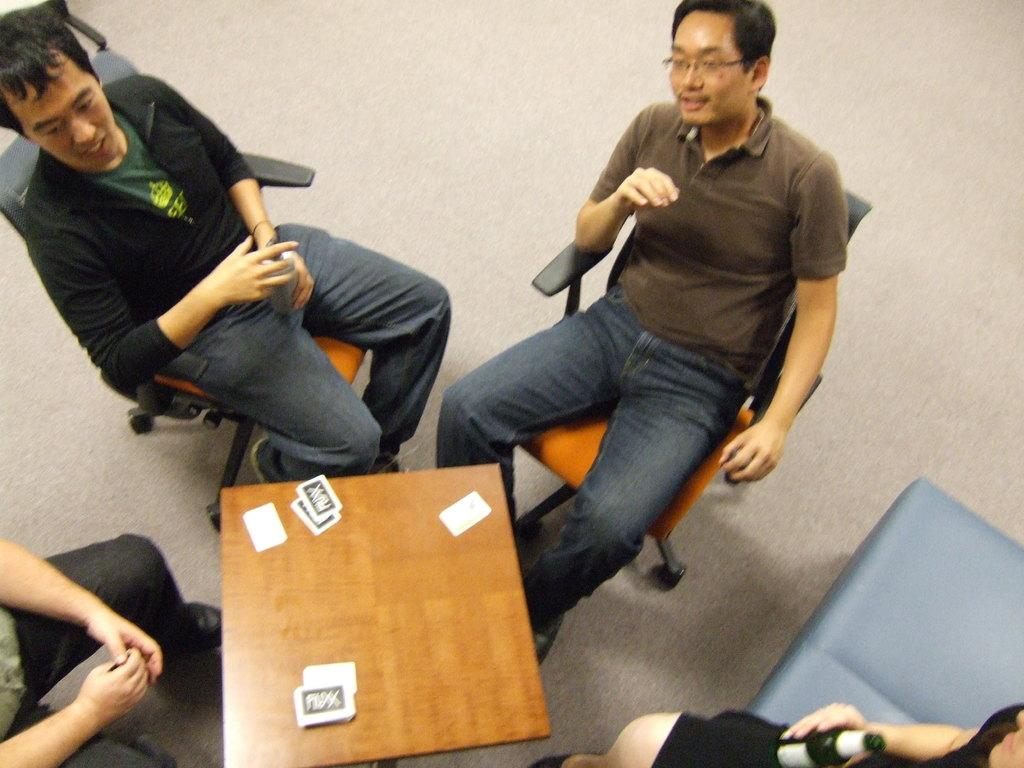What are the people in the image doing? The people in the image are sitting on chairs. What is in front of the chairs? There is a table in front of the chairs. What is on the table? There are cards on the table. What type of bomb can be seen on the table in the image? There is no bomb present on the table in the image; only cards are visible. 